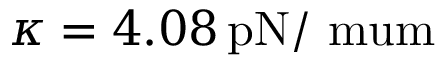Convert formula to latex. <formula><loc_0><loc_0><loc_500><loc_500>\kappa = 4 . 0 8 \, { p N / \ m u m }</formula> 